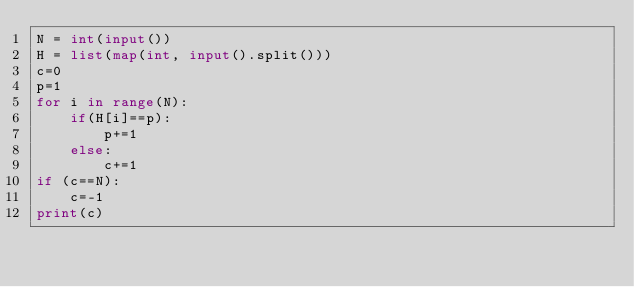<code> <loc_0><loc_0><loc_500><loc_500><_Python_>N = int(input())
H = list(map(int, input().split()))
c=0
p=1
for i in range(N):
    if(H[i]==p):
        p+=1
    else:
        c+=1
if (c==N):
    c=-1
print(c)
</code> 